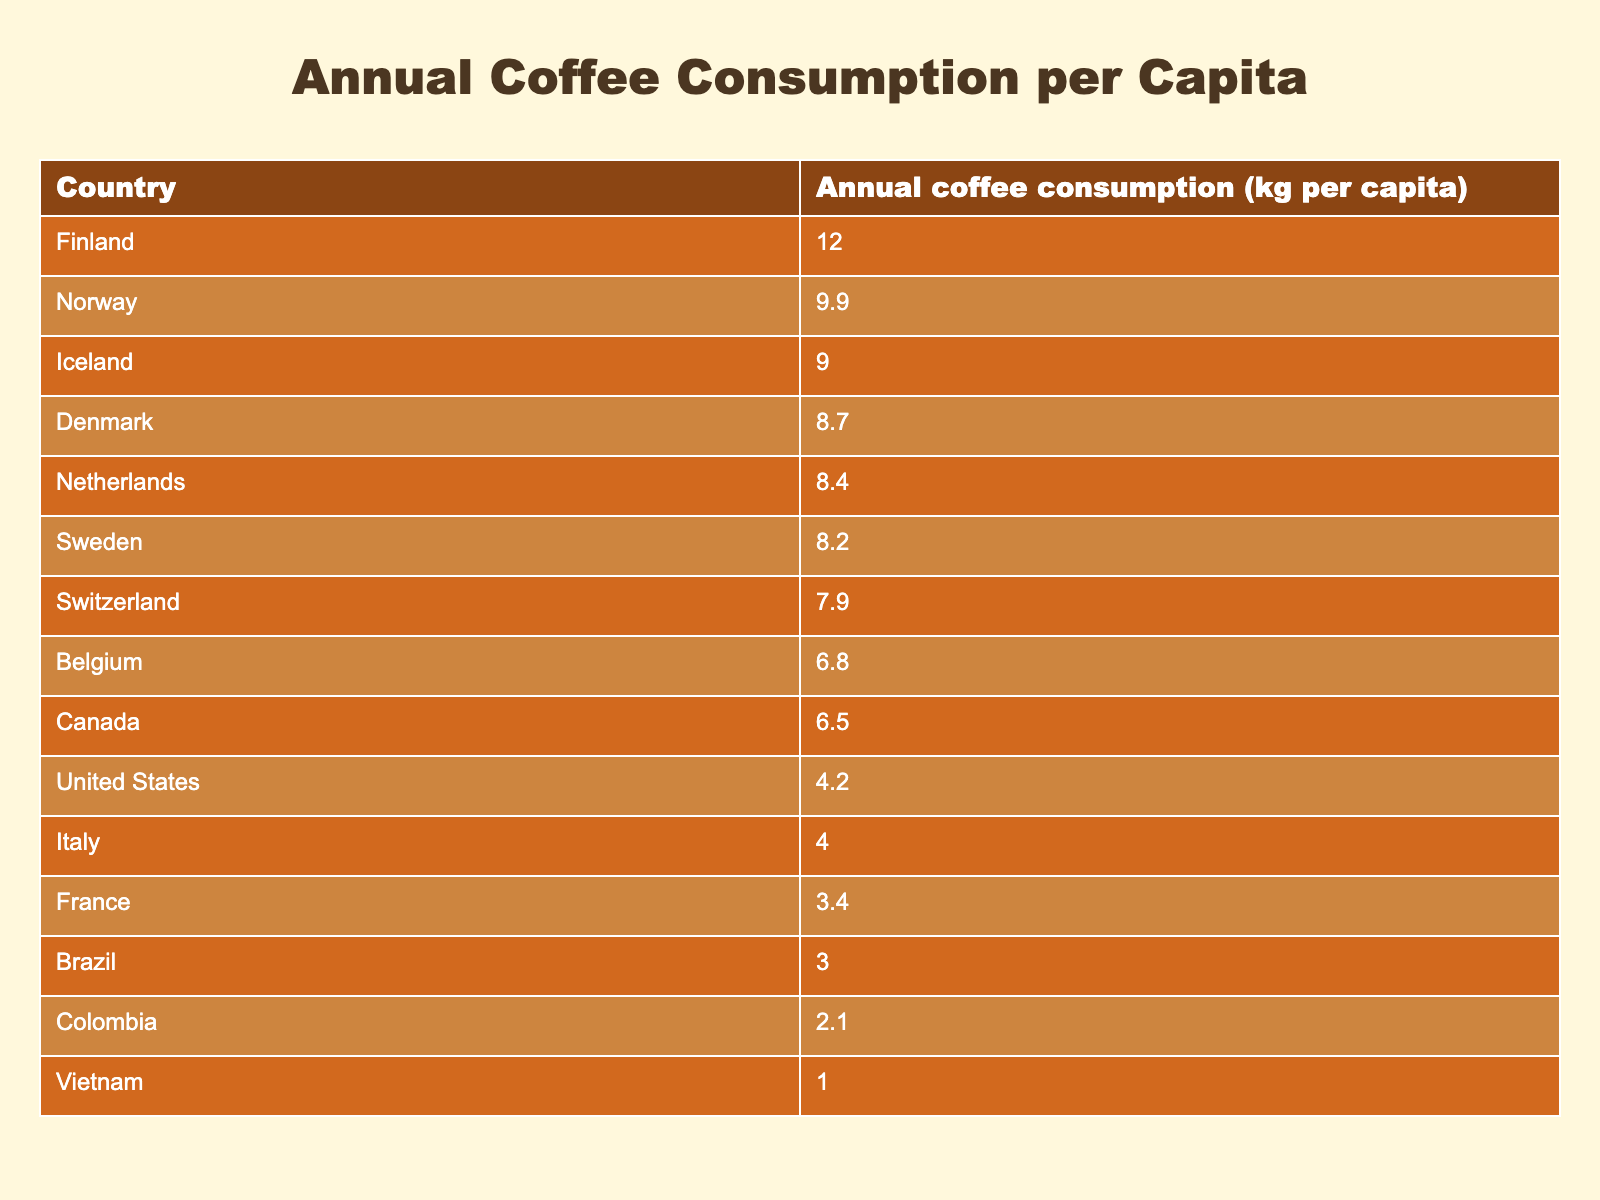What country has the highest annual coffee consumption per capita? By scanning the table, Finland is the first entry listed, and it shows an annual coffee consumption of 12.0 kg per capita, which is the highest among all countries listed.
Answer: Finland What is the annual coffee consumption of the United States? The table indicates that the United States has an annual coffee consumption of 4.2 kg per capita.
Answer: 4.2 kg Which country has lower coffee consumption, Brazil or Colombia? Brazil's annual coffee consumption is 3.0 kg per capita, while Colombia's is 2.1 kg per capita. Since 2.1 kg is less than 3.0 kg, Colombia has lower consumption.
Answer: Colombia What is the average coffee consumption of the top three countries? The top three countries are Finland (12.0 kg), Norway (9.9 kg), and Iceland (9.0 kg). To find the average, we sum these values: 12.0 + 9.9 + 9.0 = 30.9 kg, and then divide by 3, resulting in an average consumption of 30.9 / 3 = 10.3 kg.
Answer: 10.3 kg How much more coffee does Finland consume compared to the global average of the countries listed? First, we find the total coffee consumption of all countries in the table: 12.0 + 9.9 + 9.0 + 8.7 + 8.4 + 8.2 + 7.9 + 6.8 + 6.5 + 4.2 + 4.0 + 3.4 + 3.0 + 2.1 + 1.0 = 81.7 kg. There are 15 countries, so the average consumption is 81.7 / 15 = 5.45 kg. Next, we find the difference between Finland's consumption (12.0 kg) and the average (5.45 kg): 12.0 - 5.45 = 6.55 kg.
Answer: 6.55 kg Is it true that Italy consumes more coffee per capita than France? Italy has an annual coffee consumption of 4.0 kg, while France consumes 3.4 kg. Since 4.0 kg is indeed greater than 3.4 kg, the statement is true.
Answer: Yes 